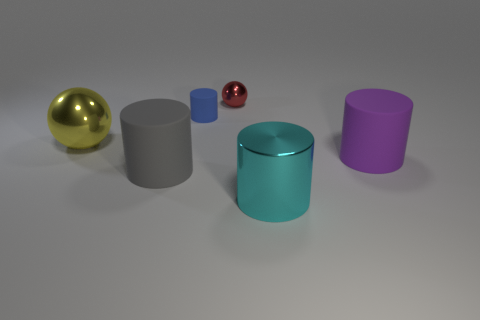What is the large cylinder left of the small metallic object made of?
Offer a very short reply. Rubber. Are there fewer purple cylinders than small gray metal spheres?
Provide a succinct answer. No. Is the shape of the purple matte object the same as the metal object that is on the left side of the gray matte cylinder?
Your answer should be very brief. No. There is a rubber object that is in front of the small matte cylinder and on the left side of the large purple cylinder; what is its shape?
Give a very brief answer. Cylinder. Are there an equal number of big yellow metal balls in front of the big purple matte cylinder and rubber things that are on the left side of the large yellow shiny object?
Ensure brevity in your answer.  Yes. Does the tiny thing on the right side of the tiny blue rubber thing have the same shape as the cyan object?
Offer a terse response. No. What number of gray things are cylinders or matte things?
Your answer should be compact. 1. What is the material of the gray object that is the same shape as the large cyan thing?
Give a very brief answer. Rubber. There is a large metal thing to the left of the tiny shiny ball; what is its shape?
Your answer should be compact. Sphere. Is there a small red block made of the same material as the small red ball?
Your answer should be very brief. No. 